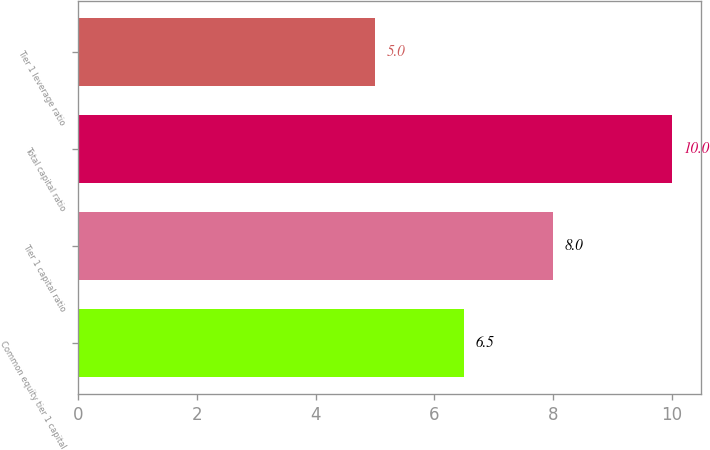Convert chart. <chart><loc_0><loc_0><loc_500><loc_500><bar_chart><fcel>Common equity tier 1 capital<fcel>Tier 1 capital ratio<fcel>Total capital ratio<fcel>Tier 1 leverage ratio<nl><fcel>6.5<fcel>8<fcel>10<fcel>5<nl></chart> 